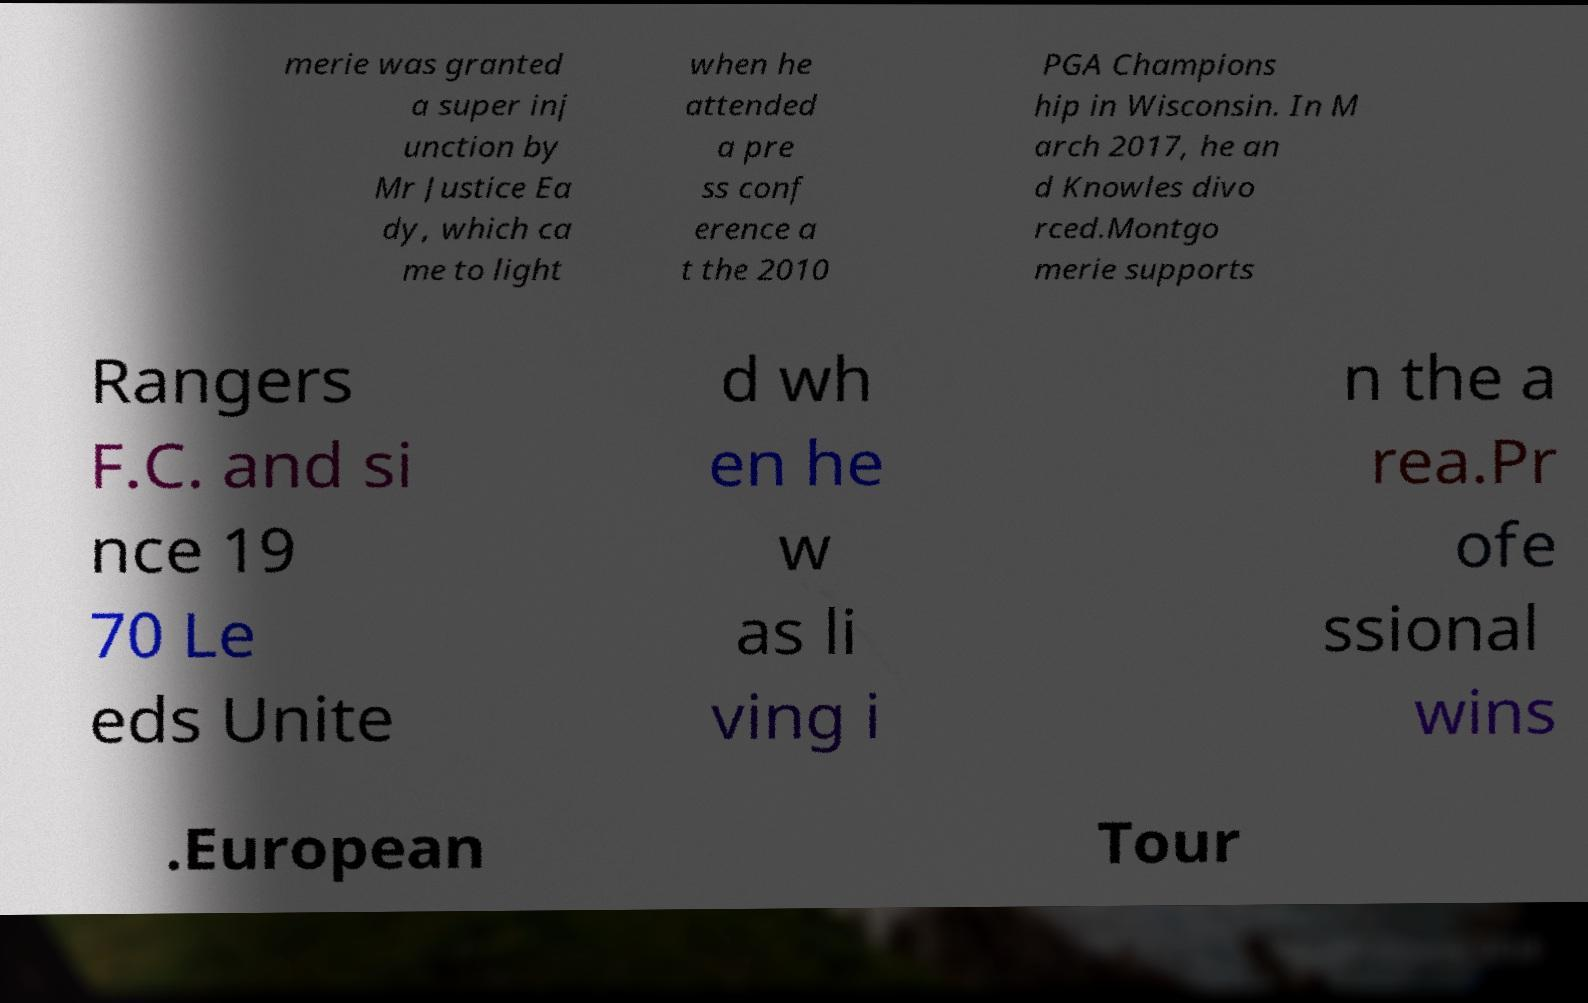There's text embedded in this image that I need extracted. Can you transcribe it verbatim? merie was granted a super inj unction by Mr Justice Ea dy, which ca me to light when he attended a pre ss conf erence a t the 2010 PGA Champions hip in Wisconsin. In M arch 2017, he an d Knowles divo rced.Montgo merie supports Rangers F.C. and si nce 19 70 Le eds Unite d wh en he w as li ving i n the a rea.Pr ofe ssional wins .European Tour 